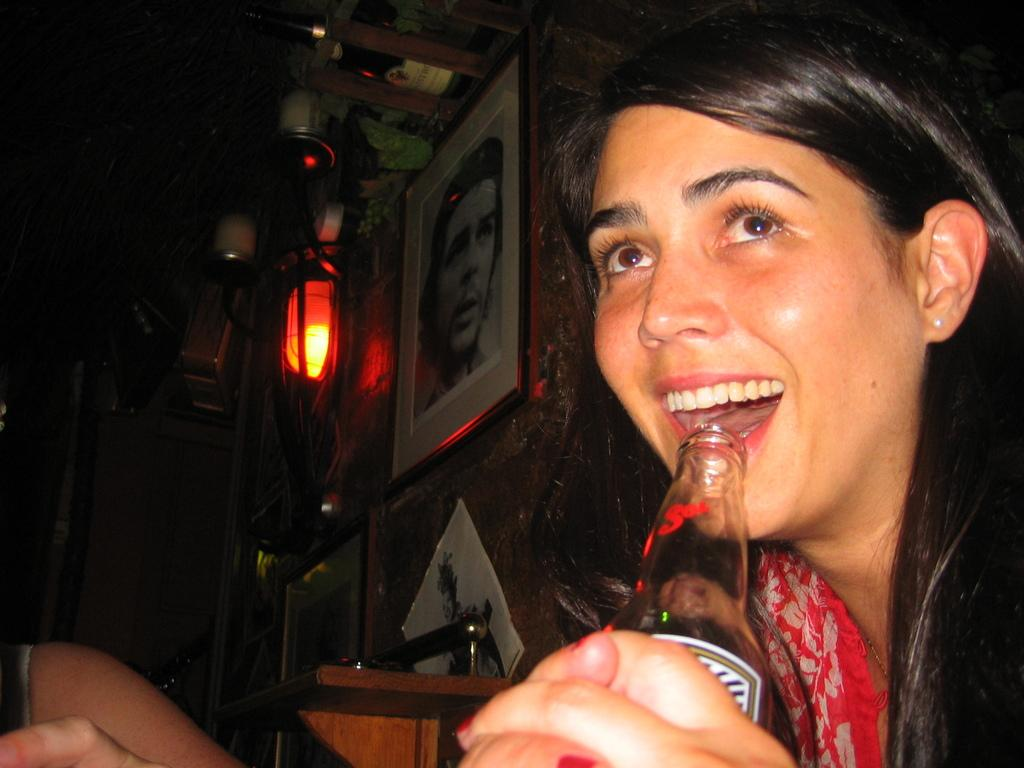What is on the right side of the image? There is a woman on the right side of the image. What is the woman holding in the image? The woman is holding a bottle. What is the woman's facial expression in the image? The woman is smiling. How would you describe the background of the image? The background of the image is dark. What can be seen on the wall in the background? There are photo frames on the wall in the background. What other objects are visible in the background? There are lamps in the background. How many ants can be seen crawling on the woman's hands in the image? There are no ants visible on the woman's hands in the image. What type of wall is depicted in the image? The image does not show a wall; it shows a woman holding a bottle and smiling in a dark background with photo frames and lamps in the background. 